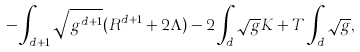<formula> <loc_0><loc_0><loc_500><loc_500>- \int _ { d + 1 } \sqrt { g ^ { d + 1 } } ( R ^ { d + 1 } + 2 \Lambda ) - 2 \int _ { d } \sqrt { g } K + T \int _ { d } \sqrt { g } ,</formula> 